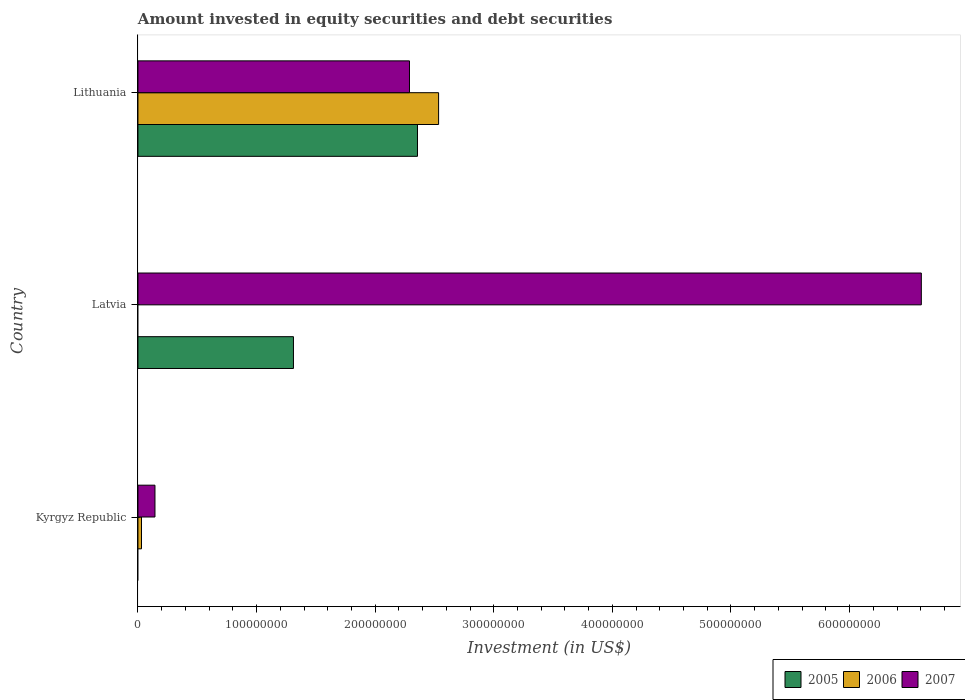How many different coloured bars are there?
Your answer should be very brief. 3. How many groups of bars are there?
Offer a very short reply. 3. Are the number of bars on each tick of the Y-axis equal?
Offer a terse response. No. How many bars are there on the 3rd tick from the bottom?
Your response must be concise. 3. What is the label of the 2nd group of bars from the top?
Ensure brevity in your answer.  Latvia. In how many cases, is the number of bars for a given country not equal to the number of legend labels?
Your answer should be compact. 2. What is the amount invested in equity securities and debt securities in 2006 in Latvia?
Give a very brief answer. 0. Across all countries, what is the maximum amount invested in equity securities and debt securities in 2005?
Provide a short and direct response. 2.36e+08. Across all countries, what is the minimum amount invested in equity securities and debt securities in 2005?
Give a very brief answer. 0. In which country was the amount invested in equity securities and debt securities in 2005 maximum?
Make the answer very short. Lithuania. What is the total amount invested in equity securities and debt securities in 2007 in the graph?
Your answer should be compact. 9.04e+08. What is the difference between the amount invested in equity securities and debt securities in 2006 in Kyrgyz Republic and that in Lithuania?
Keep it short and to the point. -2.50e+08. What is the difference between the amount invested in equity securities and debt securities in 2005 in Kyrgyz Republic and the amount invested in equity securities and debt securities in 2007 in Latvia?
Offer a terse response. -6.60e+08. What is the average amount invested in equity securities and debt securities in 2005 per country?
Your answer should be compact. 1.22e+08. What is the difference between the amount invested in equity securities and debt securities in 2006 and amount invested in equity securities and debt securities in 2005 in Lithuania?
Offer a terse response. 1.78e+07. What is the ratio of the amount invested in equity securities and debt securities in 2007 in Kyrgyz Republic to that in Latvia?
Keep it short and to the point. 0.02. Is the amount invested in equity securities and debt securities in 2007 in Kyrgyz Republic less than that in Lithuania?
Offer a very short reply. Yes. What is the difference between the highest and the second highest amount invested in equity securities and debt securities in 2007?
Give a very brief answer. 4.32e+08. What is the difference between the highest and the lowest amount invested in equity securities and debt securities in 2005?
Your answer should be compact. 2.36e+08. What is the difference between two consecutive major ticks on the X-axis?
Give a very brief answer. 1.00e+08. Are the values on the major ticks of X-axis written in scientific E-notation?
Offer a terse response. No. How are the legend labels stacked?
Your response must be concise. Horizontal. What is the title of the graph?
Ensure brevity in your answer.  Amount invested in equity securities and debt securities. What is the label or title of the X-axis?
Ensure brevity in your answer.  Investment (in US$). What is the label or title of the Y-axis?
Provide a short and direct response. Country. What is the Investment (in US$) in 2005 in Kyrgyz Republic?
Give a very brief answer. 0. What is the Investment (in US$) of 2006 in Kyrgyz Republic?
Make the answer very short. 2.98e+06. What is the Investment (in US$) in 2007 in Kyrgyz Republic?
Provide a short and direct response. 1.43e+07. What is the Investment (in US$) in 2005 in Latvia?
Your answer should be compact. 1.31e+08. What is the Investment (in US$) in 2006 in Latvia?
Offer a very short reply. 0. What is the Investment (in US$) in 2007 in Latvia?
Make the answer very short. 6.60e+08. What is the Investment (in US$) in 2005 in Lithuania?
Provide a succinct answer. 2.36e+08. What is the Investment (in US$) of 2006 in Lithuania?
Your answer should be compact. 2.53e+08. What is the Investment (in US$) in 2007 in Lithuania?
Your answer should be compact. 2.29e+08. Across all countries, what is the maximum Investment (in US$) of 2005?
Offer a very short reply. 2.36e+08. Across all countries, what is the maximum Investment (in US$) of 2006?
Make the answer very short. 2.53e+08. Across all countries, what is the maximum Investment (in US$) of 2007?
Offer a very short reply. 6.60e+08. Across all countries, what is the minimum Investment (in US$) in 2005?
Provide a succinct answer. 0. Across all countries, what is the minimum Investment (in US$) of 2006?
Make the answer very short. 0. Across all countries, what is the minimum Investment (in US$) in 2007?
Provide a short and direct response. 1.43e+07. What is the total Investment (in US$) of 2005 in the graph?
Offer a terse response. 3.67e+08. What is the total Investment (in US$) in 2006 in the graph?
Give a very brief answer. 2.56e+08. What is the total Investment (in US$) of 2007 in the graph?
Give a very brief answer. 9.04e+08. What is the difference between the Investment (in US$) of 2007 in Kyrgyz Republic and that in Latvia?
Provide a succinct answer. -6.46e+08. What is the difference between the Investment (in US$) in 2006 in Kyrgyz Republic and that in Lithuania?
Offer a terse response. -2.50e+08. What is the difference between the Investment (in US$) in 2007 in Kyrgyz Republic and that in Lithuania?
Give a very brief answer. -2.15e+08. What is the difference between the Investment (in US$) in 2005 in Latvia and that in Lithuania?
Provide a short and direct response. -1.05e+08. What is the difference between the Investment (in US$) of 2007 in Latvia and that in Lithuania?
Provide a short and direct response. 4.32e+08. What is the difference between the Investment (in US$) of 2006 in Kyrgyz Republic and the Investment (in US$) of 2007 in Latvia?
Provide a succinct answer. -6.57e+08. What is the difference between the Investment (in US$) of 2006 in Kyrgyz Republic and the Investment (in US$) of 2007 in Lithuania?
Offer a very short reply. -2.26e+08. What is the difference between the Investment (in US$) of 2005 in Latvia and the Investment (in US$) of 2006 in Lithuania?
Provide a short and direct response. -1.22e+08. What is the difference between the Investment (in US$) in 2005 in Latvia and the Investment (in US$) in 2007 in Lithuania?
Provide a short and direct response. -9.78e+07. What is the average Investment (in US$) of 2005 per country?
Your response must be concise. 1.22e+08. What is the average Investment (in US$) of 2006 per country?
Your answer should be very brief. 8.55e+07. What is the average Investment (in US$) of 2007 per country?
Your response must be concise. 3.01e+08. What is the difference between the Investment (in US$) in 2006 and Investment (in US$) in 2007 in Kyrgyz Republic?
Your answer should be compact. -1.14e+07. What is the difference between the Investment (in US$) in 2005 and Investment (in US$) in 2007 in Latvia?
Offer a very short reply. -5.29e+08. What is the difference between the Investment (in US$) of 2005 and Investment (in US$) of 2006 in Lithuania?
Offer a very short reply. -1.78e+07. What is the difference between the Investment (in US$) of 2005 and Investment (in US$) of 2007 in Lithuania?
Make the answer very short. 6.75e+06. What is the difference between the Investment (in US$) in 2006 and Investment (in US$) in 2007 in Lithuania?
Provide a short and direct response. 2.45e+07. What is the ratio of the Investment (in US$) in 2007 in Kyrgyz Republic to that in Latvia?
Your response must be concise. 0.02. What is the ratio of the Investment (in US$) in 2006 in Kyrgyz Republic to that in Lithuania?
Ensure brevity in your answer.  0.01. What is the ratio of the Investment (in US$) of 2007 in Kyrgyz Republic to that in Lithuania?
Provide a short and direct response. 0.06. What is the ratio of the Investment (in US$) of 2005 in Latvia to that in Lithuania?
Your answer should be compact. 0.56. What is the ratio of the Investment (in US$) of 2007 in Latvia to that in Lithuania?
Provide a succinct answer. 2.89. What is the difference between the highest and the second highest Investment (in US$) of 2007?
Offer a very short reply. 4.32e+08. What is the difference between the highest and the lowest Investment (in US$) of 2005?
Your answer should be very brief. 2.36e+08. What is the difference between the highest and the lowest Investment (in US$) of 2006?
Your response must be concise. 2.53e+08. What is the difference between the highest and the lowest Investment (in US$) of 2007?
Your answer should be very brief. 6.46e+08. 